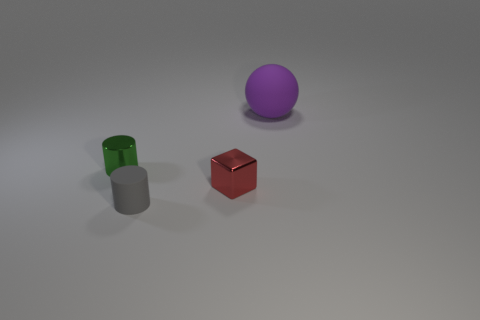There is a rubber object that is on the right side of the gray thing; does it have the same size as the cylinder in front of the metallic cube?
Offer a terse response. No. There is a matte object that is in front of the thing that is behind the tiny cylinder behind the small matte cylinder; what is its color?
Your answer should be compact. Gray. Is there a small gray object that has the same shape as the tiny red shiny thing?
Provide a succinct answer. No. Is the number of gray cylinders that are behind the large thing greater than the number of rubber things?
Offer a very short reply. No. How many rubber objects are either tiny blue spheres or small gray cylinders?
Provide a short and direct response. 1. What is the size of the object that is right of the tiny matte cylinder and left of the large matte sphere?
Provide a short and direct response. Small. There is a matte object in front of the tiny green shiny cylinder; are there any tiny metal things that are right of it?
Your answer should be very brief. Yes. There is a purple matte sphere; how many small rubber things are in front of it?
Your answer should be very brief. 1. There is another matte object that is the same shape as the green object; what is its color?
Offer a very short reply. Gray. Is the material of the small object that is in front of the tiny red object the same as the large purple thing that is on the right side of the tiny cube?
Ensure brevity in your answer.  Yes. 